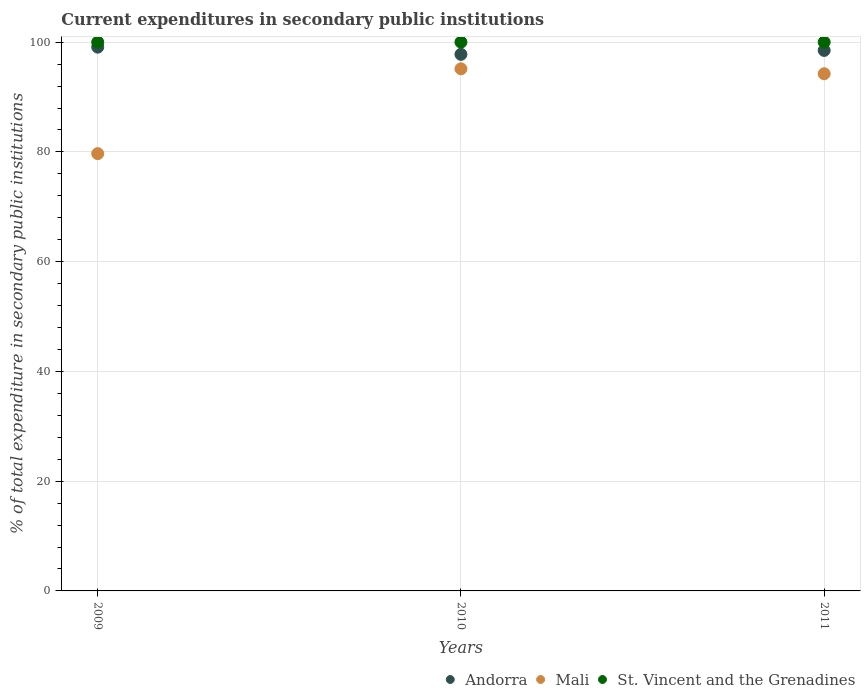Is the number of dotlines equal to the number of legend labels?
Give a very brief answer. Yes. What is the current expenditures in secondary public institutions in Mali in 2010?
Your answer should be very brief. 95.14. Across all years, what is the maximum current expenditures in secondary public institutions in St. Vincent and the Grenadines?
Keep it short and to the point. 100. Across all years, what is the minimum current expenditures in secondary public institutions in Andorra?
Give a very brief answer. 97.78. In which year was the current expenditures in secondary public institutions in Mali minimum?
Your answer should be compact. 2009. What is the total current expenditures in secondary public institutions in Mali in the graph?
Your answer should be very brief. 269.07. What is the difference between the current expenditures in secondary public institutions in Mali in 2009 and that in 2011?
Make the answer very short. -14.55. What is the difference between the current expenditures in secondary public institutions in Andorra in 2011 and the current expenditures in secondary public institutions in Mali in 2009?
Your response must be concise. 18.81. What is the average current expenditures in secondary public institutions in St. Vincent and the Grenadines per year?
Give a very brief answer. 100. In the year 2010, what is the difference between the current expenditures in secondary public institutions in St. Vincent and the Grenadines and current expenditures in secondary public institutions in Andorra?
Offer a terse response. 2.22. What is the ratio of the current expenditures in secondary public institutions in St. Vincent and the Grenadines in 2009 to that in 2011?
Offer a very short reply. 1. Is the difference between the current expenditures in secondary public institutions in St. Vincent and the Grenadines in 2009 and 2010 greater than the difference between the current expenditures in secondary public institutions in Andorra in 2009 and 2010?
Offer a terse response. No. What is the difference between the highest and the second highest current expenditures in secondary public institutions in Mali?
Give a very brief answer. 0.9. What is the difference between the highest and the lowest current expenditures in secondary public institutions in Andorra?
Your response must be concise. 1.31. In how many years, is the current expenditures in secondary public institutions in Andorra greater than the average current expenditures in secondary public institutions in Andorra taken over all years?
Make the answer very short. 2. Does the current expenditures in secondary public institutions in Andorra monotonically increase over the years?
Offer a terse response. No. Is the current expenditures in secondary public institutions in Andorra strictly less than the current expenditures in secondary public institutions in Mali over the years?
Provide a short and direct response. No. How many dotlines are there?
Keep it short and to the point. 3. What is the difference between two consecutive major ticks on the Y-axis?
Give a very brief answer. 20. Are the values on the major ticks of Y-axis written in scientific E-notation?
Your answer should be very brief. No. Does the graph contain grids?
Give a very brief answer. Yes. How many legend labels are there?
Make the answer very short. 3. What is the title of the graph?
Ensure brevity in your answer.  Current expenditures in secondary public institutions. Does "Saudi Arabia" appear as one of the legend labels in the graph?
Offer a terse response. No. What is the label or title of the X-axis?
Ensure brevity in your answer.  Years. What is the label or title of the Y-axis?
Your answer should be compact. % of total expenditure in secondary public institutions. What is the % of total expenditure in secondary public institutions in Andorra in 2009?
Provide a succinct answer. 99.09. What is the % of total expenditure in secondary public institutions of Mali in 2009?
Give a very brief answer. 79.69. What is the % of total expenditure in secondary public institutions in Andorra in 2010?
Ensure brevity in your answer.  97.78. What is the % of total expenditure in secondary public institutions of Mali in 2010?
Keep it short and to the point. 95.14. What is the % of total expenditure in secondary public institutions of Andorra in 2011?
Provide a succinct answer. 98.49. What is the % of total expenditure in secondary public institutions in Mali in 2011?
Make the answer very short. 94.24. What is the % of total expenditure in secondary public institutions of St. Vincent and the Grenadines in 2011?
Provide a short and direct response. 100. Across all years, what is the maximum % of total expenditure in secondary public institutions in Andorra?
Offer a very short reply. 99.09. Across all years, what is the maximum % of total expenditure in secondary public institutions in Mali?
Offer a terse response. 95.14. Across all years, what is the maximum % of total expenditure in secondary public institutions in St. Vincent and the Grenadines?
Provide a short and direct response. 100. Across all years, what is the minimum % of total expenditure in secondary public institutions of Andorra?
Your response must be concise. 97.78. Across all years, what is the minimum % of total expenditure in secondary public institutions of Mali?
Ensure brevity in your answer.  79.69. What is the total % of total expenditure in secondary public institutions in Andorra in the graph?
Your answer should be compact. 295.36. What is the total % of total expenditure in secondary public institutions of Mali in the graph?
Provide a short and direct response. 269.07. What is the total % of total expenditure in secondary public institutions in St. Vincent and the Grenadines in the graph?
Your answer should be very brief. 300. What is the difference between the % of total expenditure in secondary public institutions of Andorra in 2009 and that in 2010?
Keep it short and to the point. 1.31. What is the difference between the % of total expenditure in secondary public institutions of Mali in 2009 and that in 2010?
Make the answer very short. -15.45. What is the difference between the % of total expenditure in secondary public institutions of St. Vincent and the Grenadines in 2009 and that in 2010?
Give a very brief answer. 0. What is the difference between the % of total expenditure in secondary public institutions of Andorra in 2009 and that in 2011?
Provide a short and direct response. 0.6. What is the difference between the % of total expenditure in secondary public institutions in Mali in 2009 and that in 2011?
Provide a short and direct response. -14.55. What is the difference between the % of total expenditure in secondary public institutions in Andorra in 2010 and that in 2011?
Make the answer very short. -0.72. What is the difference between the % of total expenditure in secondary public institutions in Mali in 2010 and that in 2011?
Offer a very short reply. 0.9. What is the difference between the % of total expenditure in secondary public institutions of St. Vincent and the Grenadines in 2010 and that in 2011?
Give a very brief answer. 0. What is the difference between the % of total expenditure in secondary public institutions in Andorra in 2009 and the % of total expenditure in secondary public institutions in Mali in 2010?
Provide a succinct answer. 3.95. What is the difference between the % of total expenditure in secondary public institutions in Andorra in 2009 and the % of total expenditure in secondary public institutions in St. Vincent and the Grenadines in 2010?
Offer a very short reply. -0.91. What is the difference between the % of total expenditure in secondary public institutions of Mali in 2009 and the % of total expenditure in secondary public institutions of St. Vincent and the Grenadines in 2010?
Make the answer very short. -20.31. What is the difference between the % of total expenditure in secondary public institutions in Andorra in 2009 and the % of total expenditure in secondary public institutions in Mali in 2011?
Your answer should be very brief. 4.85. What is the difference between the % of total expenditure in secondary public institutions in Andorra in 2009 and the % of total expenditure in secondary public institutions in St. Vincent and the Grenadines in 2011?
Make the answer very short. -0.91. What is the difference between the % of total expenditure in secondary public institutions of Mali in 2009 and the % of total expenditure in secondary public institutions of St. Vincent and the Grenadines in 2011?
Offer a terse response. -20.31. What is the difference between the % of total expenditure in secondary public institutions of Andorra in 2010 and the % of total expenditure in secondary public institutions of Mali in 2011?
Keep it short and to the point. 3.54. What is the difference between the % of total expenditure in secondary public institutions in Andorra in 2010 and the % of total expenditure in secondary public institutions in St. Vincent and the Grenadines in 2011?
Offer a very short reply. -2.22. What is the difference between the % of total expenditure in secondary public institutions of Mali in 2010 and the % of total expenditure in secondary public institutions of St. Vincent and the Grenadines in 2011?
Offer a terse response. -4.86. What is the average % of total expenditure in secondary public institutions in Andorra per year?
Make the answer very short. 98.45. What is the average % of total expenditure in secondary public institutions in Mali per year?
Provide a succinct answer. 89.69. What is the average % of total expenditure in secondary public institutions of St. Vincent and the Grenadines per year?
Ensure brevity in your answer.  100. In the year 2009, what is the difference between the % of total expenditure in secondary public institutions in Andorra and % of total expenditure in secondary public institutions in Mali?
Your answer should be compact. 19.4. In the year 2009, what is the difference between the % of total expenditure in secondary public institutions of Andorra and % of total expenditure in secondary public institutions of St. Vincent and the Grenadines?
Offer a very short reply. -0.91. In the year 2009, what is the difference between the % of total expenditure in secondary public institutions in Mali and % of total expenditure in secondary public institutions in St. Vincent and the Grenadines?
Provide a short and direct response. -20.31. In the year 2010, what is the difference between the % of total expenditure in secondary public institutions in Andorra and % of total expenditure in secondary public institutions in Mali?
Keep it short and to the point. 2.63. In the year 2010, what is the difference between the % of total expenditure in secondary public institutions of Andorra and % of total expenditure in secondary public institutions of St. Vincent and the Grenadines?
Offer a very short reply. -2.22. In the year 2010, what is the difference between the % of total expenditure in secondary public institutions in Mali and % of total expenditure in secondary public institutions in St. Vincent and the Grenadines?
Offer a terse response. -4.86. In the year 2011, what is the difference between the % of total expenditure in secondary public institutions in Andorra and % of total expenditure in secondary public institutions in Mali?
Give a very brief answer. 4.25. In the year 2011, what is the difference between the % of total expenditure in secondary public institutions in Andorra and % of total expenditure in secondary public institutions in St. Vincent and the Grenadines?
Ensure brevity in your answer.  -1.51. In the year 2011, what is the difference between the % of total expenditure in secondary public institutions in Mali and % of total expenditure in secondary public institutions in St. Vincent and the Grenadines?
Your response must be concise. -5.76. What is the ratio of the % of total expenditure in secondary public institutions in Andorra in 2009 to that in 2010?
Your answer should be very brief. 1.01. What is the ratio of the % of total expenditure in secondary public institutions of Mali in 2009 to that in 2010?
Give a very brief answer. 0.84. What is the ratio of the % of total expenditure in secondary public institutions in Mali in 2009 to that in 2011?
Your answer should be compact. 0.85. What is the ratio of the % of total expenditure in secondary public institutions in St. Vincent and the Grenadines in 2009 to that in 2011?
Provide a succinct answer. 1. What is the ratio of the % of total expenditure in secondary public institutions in Mali in 2010 to that in 2011?
Your response must be concise. 1.01. What is the ratio of the % of total expenditure in secondary public institutions of St. Vincent and the Grenadines in 2010 to that in 2011?
Offer a terse response. 1. What is the difference between the highest and the second highest % of total expenditure in secondary public institutions in Andorra?
Keep it short and to the point. 0.6. What is the difference between the highest and the second highest % of total expenditure in secondary public institutions in Mali?
Offer a very short reply. 0.9. What is the difference between the highest and the second highest % of total expenditure in secondary public institutions in St. Vincent and the Grenadines?
Provide a short and direct response. 0. What is the difference between the highest and the lowest % of total expenditure in secondary public institutions in Andorra?
Offer a terse response. 1.31. What is the difference between the highest and the lowest % of total expenditure in secondary public institutions of Mali?
Provide a succinct answer. 15.45. What is the difference between the highest and the lowest % of total expenditure in secondary public institutions of St. Vincent and the Grenadines?
Make the answer very short. 0. 